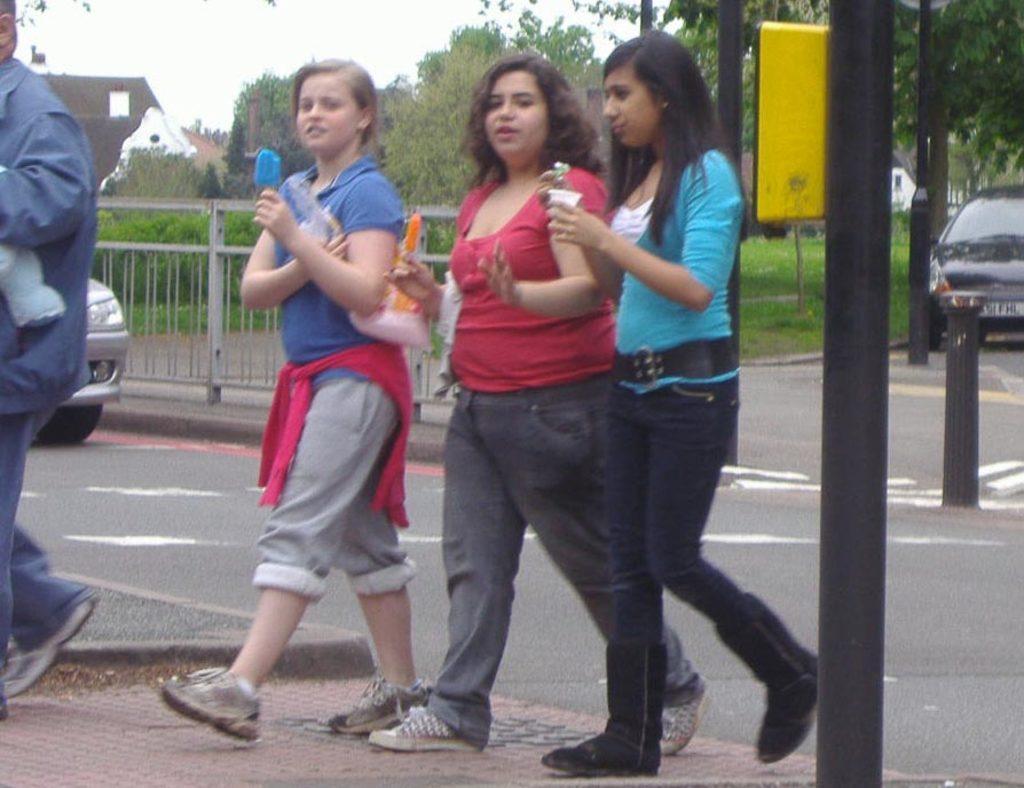In one or two sentences, can you explain what this image depicts? In this picture I can see there are three women walking here and in the backdrop there are vehicles moving and there are plants and trees. 